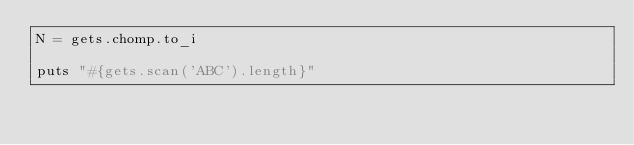Convert code to text. <code><loc_0><loc_0><loc_500><loc_500><_Ruby_>N = gets.chomp.to_i

puts "#{gets.scan('ABC').length}"</code> 